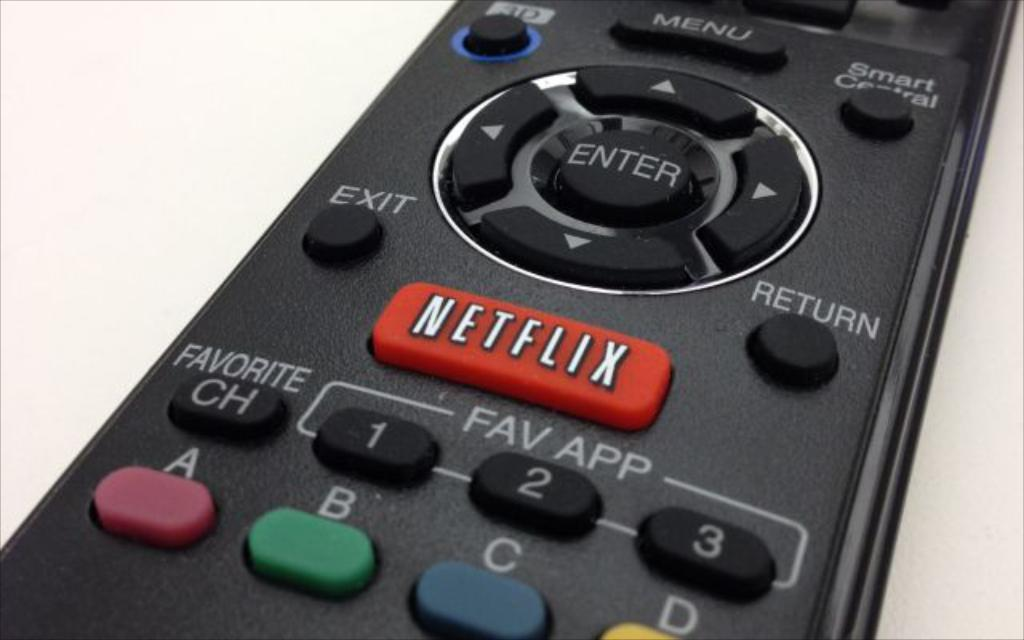<image>
Create a compact narrative representing the image presented. The television remote control features a button that will take user directly to Netflix. 